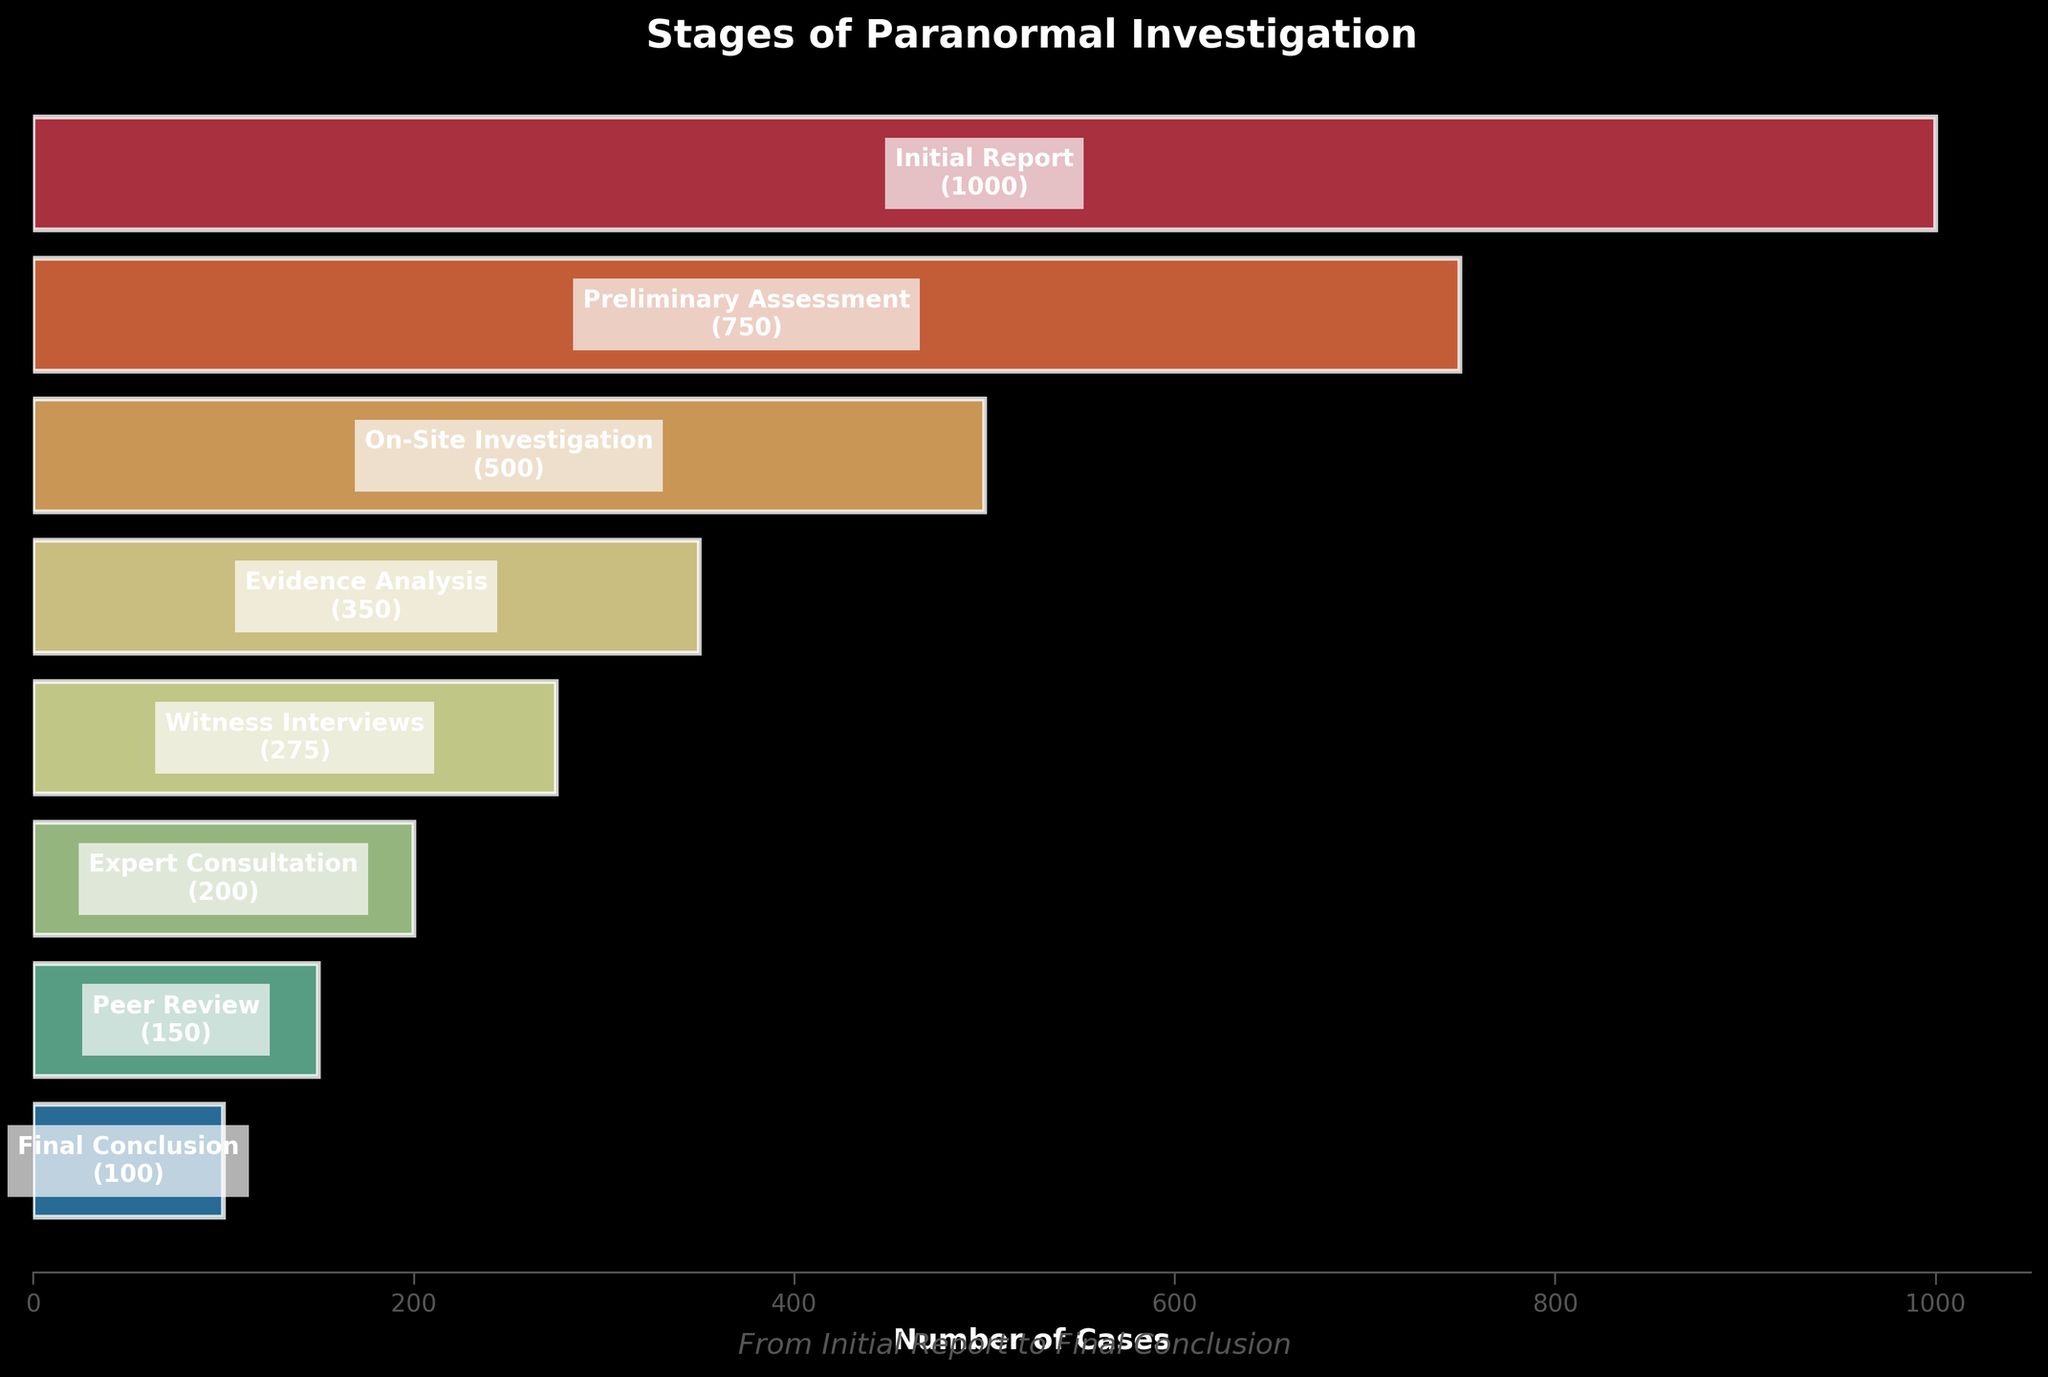What's the title of the figure? The title of the figure can be found at the top of the plot, which generally summarizes what the plot is about.
Answer: Stages of Paranormal Investigation How many stages are there in the paranormal investigation process? Counting the number of different labels on the vertical axis or within the bars indicates the number of stages.
Answer: Eight What is the difference in the number of cases between the Initial Report and Final Conclusion stages? Subtract the number of cases at the Final Conclusion stage from the number of cases at the Initial Report stage, i.e., 1000 - 100.
Answer: 900 In which stage does the steepest drop in the number of cases occur? Compare the difference in the number of cases between consecutive stages; the largest difference will indicate the steepest drop.
Answer: Initial Report to Preliminary Assessment Which stage involves more cases, Preliminary Assessment or Evidence Analysis? Directly compare the lengths of the bars representing Preliminary Assessment and Evidence Analysis.
Answer: Preliminary Assessment What percentage of the initial reports advance to the Final Conclusion stage? Divide the number of cases in the Final Conclusion stage by the number of cases in the Initial Report stage and multiply by 100 to get the percentage, i.e., (100/1000) * 100.
Answer: 10% What is the sum of the number of cases in the Preliminary Assessment and On-Site Investigation stages? Add the number of cases in the Preliminary Assessment stage to that in the On-Site Investigation stage, i.e., 750 + 500.
Answer: 1250 Which stages have fewer than 300 cases? Identify the stages with bars representing fewer than 300 cases by looking at the numeric annotations.
Answer: Witness Interviews, Expert Consultation, Peer Review, and Final Conclusion How does the number of cases in Witness Interviews compare to Expert Consultation? Directly compare the lengths of the bars for Witness Interviews and Expert Consultation. Witness Interviews has 275 cases, and Expert Consultation has 200 cases.
Answer: Witness Interviews has more What is the median number of cases across all stages? List the number of cases (1000, 750, 500, 350, 275, 200, 150, 100), sort them and find the middle value(s). Since there are eight stages, the median is the average of the 4th and 5th values, i.e., (350 + 275)/2.
Answer: 312.5 